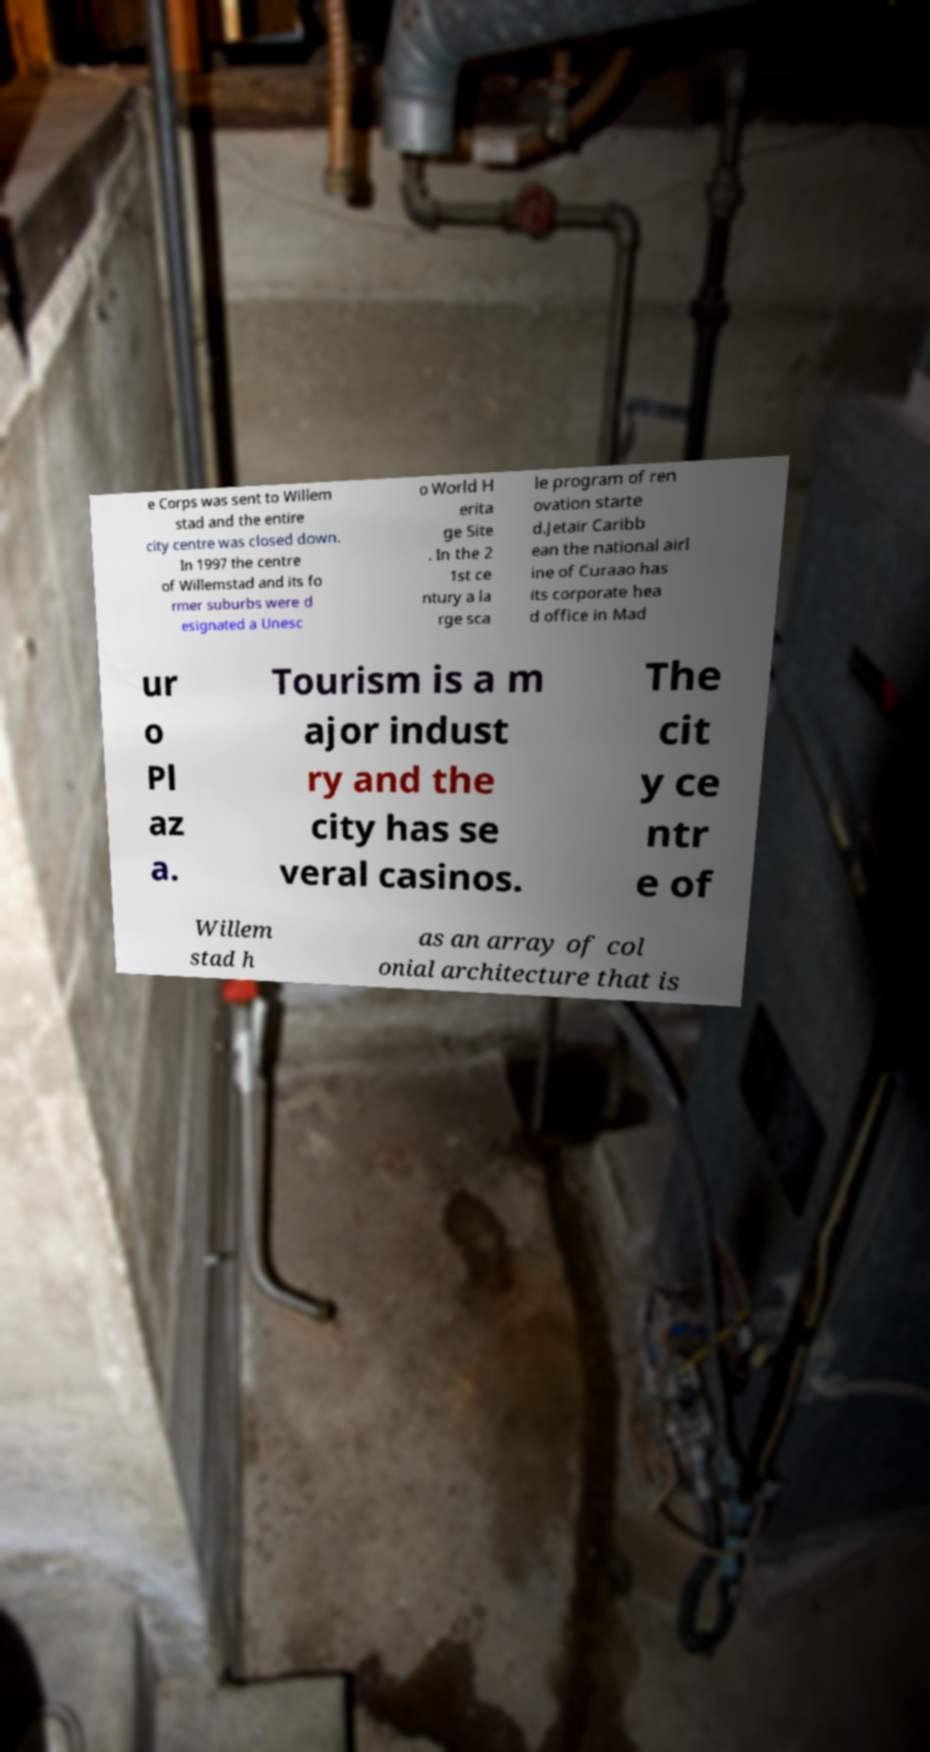Could you assist in decoding the text presented in this image and type it out clearly? e Corps was sent to Willem stad and the entire city centre was closed down. In 1997 the centre of Willemstad and its fo rmer suburbs were d esignated a Unesc o World H erita ge Site . In the 2 1st ce ntury a la rge sca le program of ren ovation starte d.Jetair Caribb ean the national airl ine of Curaao has its corporate hea d office in Mad ur o Pl az a. Tourism is a m ajor indust ry and the city has se veral casinos. The cit y ce ntr e of Willem stad h as an array of col onial architecture that is 